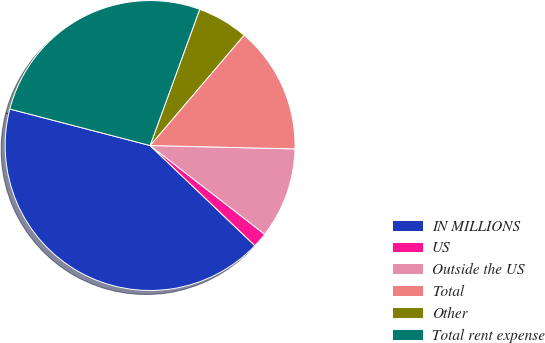<chart> <loc_0><loc_0><loc_500><loc_500><pie_chart><fcel>IN MILLIONS<fcel>US<fcel>Outside the US<fcel>Total<fcel>Other<fcel>Total rent expense<nl><fcel>41.91%<fcel>1.65%<fcel>10.12%<fcel>14.14%<fcel>5.67%<fcel>26.51%<nl></chart> 